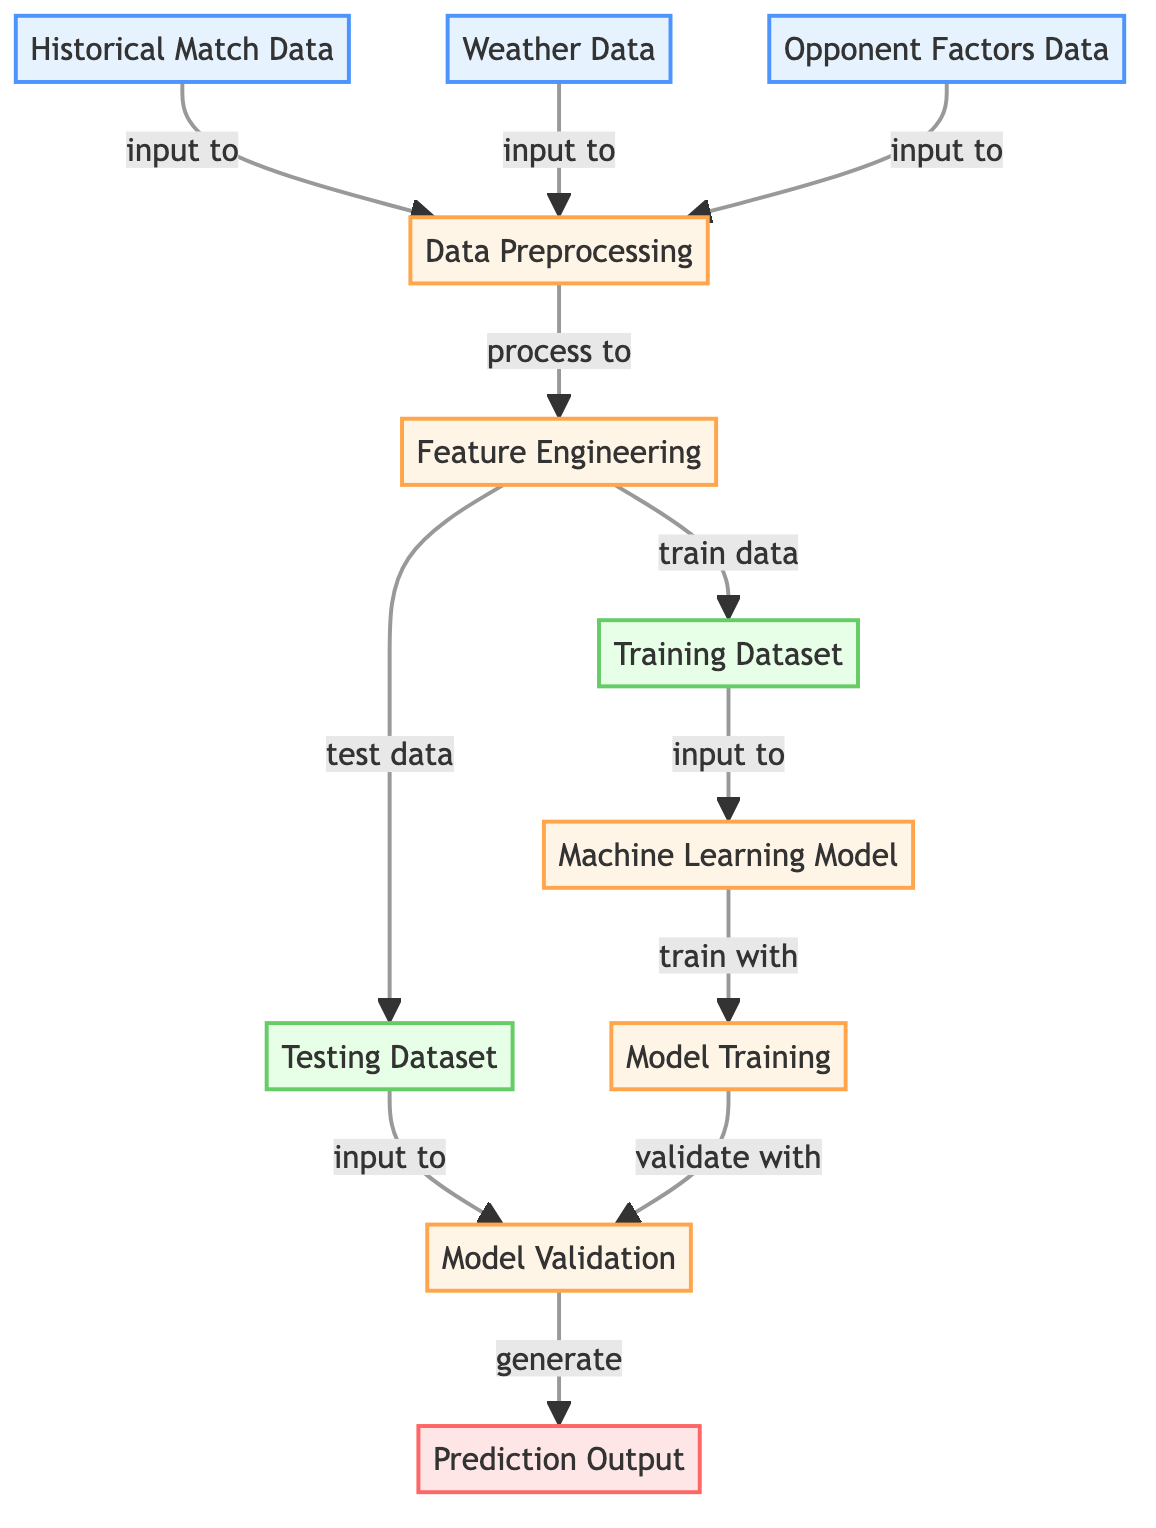What are the three types of input data in the diagram? The diagram shows three distinct input data sources: "Historical Match Data," "Weather Data," and "Opponent Factors Data." Each of these inputs is clearly labeled at the beginning of the flowchart.
Answer: Historical Match Data, Weather Data, Opponent Factors Data What is the first processing step after data input? Following the input data sources, the first processing step is "Data Preprocessing." This step connects directly from the input nodes, indicating it is the initial transformation stage.
Answer: Data Preprocessing How many datasets are generated after Feature Engineering? The "Feature Engineering" process outputs two datasets, labeled as "Training Dataset" and "Testing Dataset." This is visually shown by the arrows leading to both dataset nodes from the Feature Engineering node.
Answer: 2 Which node receives input from both Training Dataset and Testing Dataset? The "Machine Learning Model" node receives input from both the "Training Dataset" and the "Testing Dataset." This combines the processed data for further analysis.
Answer: Machine Learning Model What is the relationship between Model Training and Model Validation? "Model Training" precedes "Model Validation." The training process involves creating the model, which is then validated using the testing data to ensure its accuracy. The connections in the flowchart illustrate this sequential relationship.
Answer: Sequential What generates the Prediction Output in the diagram? The "Model Validation" process generates the "Prediction Output." This indicates the final outcome of the model validation step is the predictions regarding match attendance.
Answer: Model Validation Which data types are combined and processed in Feature Engineering? The "Feature Engineering" process combines and processes both "Historical Match Data" and "Weather Data," as indicated by the connections in the diagram leading to the feature engineering step.
Answer: Historical Match Data, Weather Data What type of diagram is represented here? This diagram falls under the category of a "Machine Learning Diagram," as it outlines the workflow and processes involved in predicting match attendance based on various inputs.
Answer: Machine Learning Diagram What is the final output of the diagram? The final output of the entire diagram is "Prediction Output," which results from validating the machine learning model and indicates the anticipated match attendance. This is shown at the end of the flowchart.
Answer: Prediction Output 